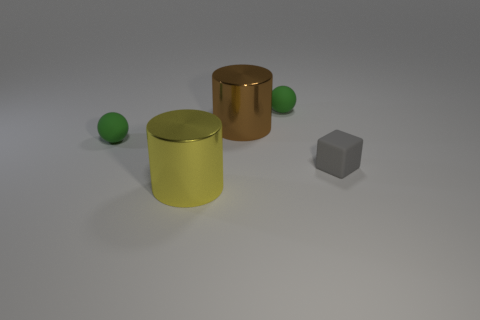What is the material of the brown cylinder that is the same size as the yellow metal object?
Your answer should be very brief. Metal. How many other things are there of the same material as the gray object?
Your response must be concise. 2. The small thing that is left of the tiny gray thing and in front of the big brown object is what color?
Ensure brevity in your answer.  Green. How many things are either green things to the right of the big yellow shiny thing or brown cubes?
Your answer should be compact. 1. Is the number of tiny green rubber objects that are in front of the brown cylinder the same as the number of large yellow shiny things?
Offer a very short reply. Yes. What number of small matte objects are on the left side of the green matte ball that is on the left side of the metallic thing behind the rubber cube?
Offer a terse response. 0. Is the size of the brown metal cylinder the same as the rubber object behind the big brown shiny thing?
Your answer should be very brief. No. What number of rubber spheres are there?
Make the answer very short. 2. Does the shiny object behind the tiny gray matte block have the same size as the ball on the right side of the large brown thing?
Provide a short and direct response. No. There is another large thing that is the same shape as the big brown shiny thing; what color is it?
Your answer should be very brief. Yellow. 